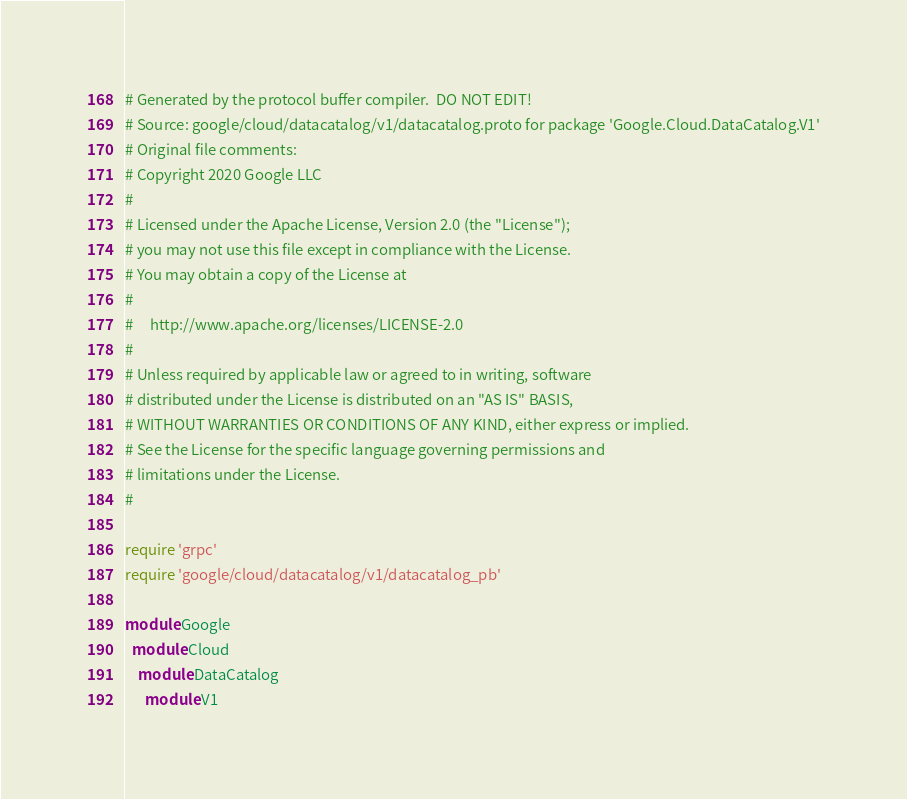<code> <loc_0><loc_0><loc_500><loc_500><_Ruby_># Generated by the protocol buffer compiler.  DO NOT EDIT!
# Source: google/cloud/datacatalog/v1/datacatalog.proto for package 'Google.Cloud.DataCatalog.V1'
# Original file comments:
# Copyright 2020 Google LLC
#
# Licensed under the Apache License, Version 2.0 (the "License");
# you may not use this file except in compliance with the License.
# You may obtain a copy of the License at
#
#     http://www.apache.org/licenses/LICENSE-2.0
#
# Unless required by applicable law or agreed to in writing, software
# distributed under the License is distributed on an "AS IS" BASIS,
# WITHOUT WARRANTIES OR CONDITIONS OF ANY KIND, either express or implied.
# See the License for the specific language governing permissions and
# limitations under the License.
#

require 'grpc'
require 'google/cloud/datacatalog/v1/datacatalog_pb'

module Google
  module Cloud
    module DataCatalog
      module V1</code> 